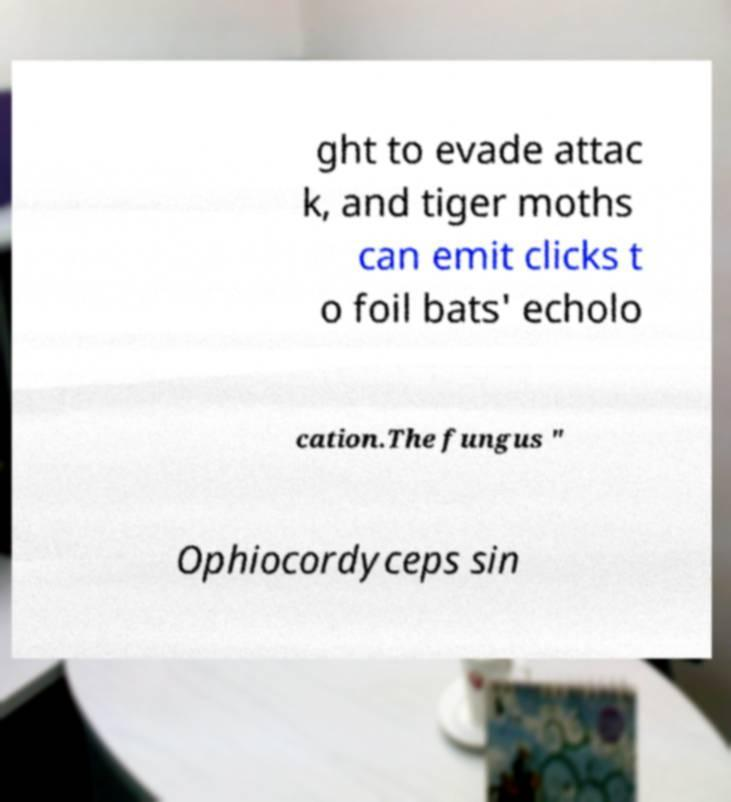Please read and relay the text visible in this image. What does it say? ght to evade attac k, and tiger moths can emit clicks t o foil bats' echolo cation.The fungus " Ophiocordyceps sin 